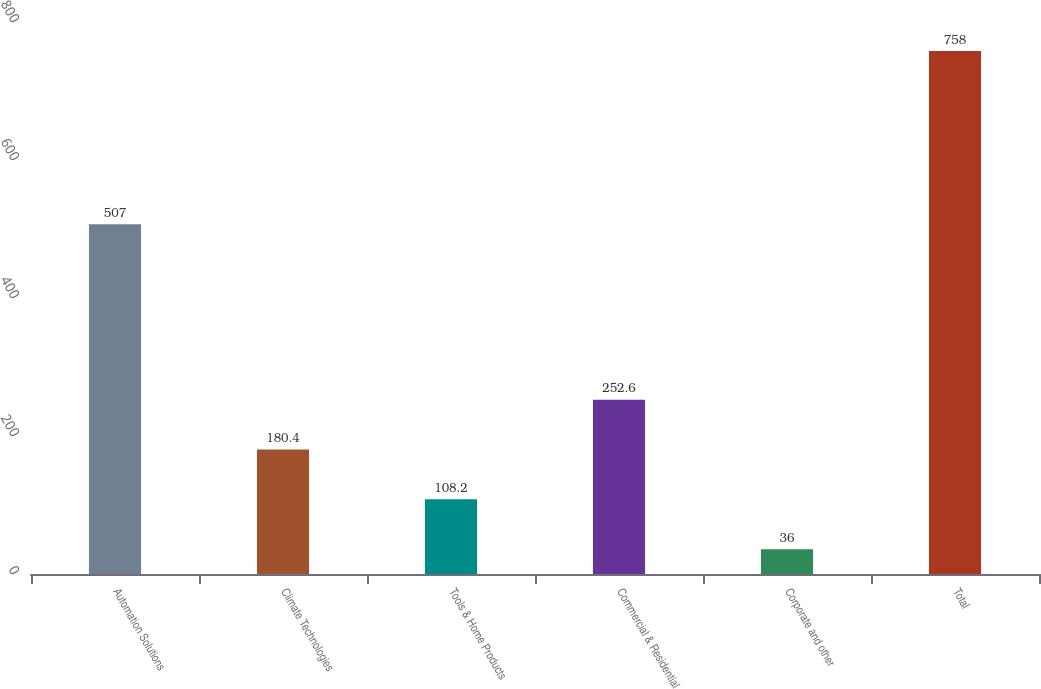Convert chart to OTSL. <chart><loc_0><loc_0><loc_500><loc_500><bar_chart><fcel>Automation Solutions<fcel>Climate Technologies<fcel>Tools & Home Products<fcel>Commercial & Residential<fcel>Corporate and other<fcel>Total<nl><fcel>507<fcel>180.4<fcel>108.2<fcel>252.6<fcel>36<fcel>758<nl></chart> 